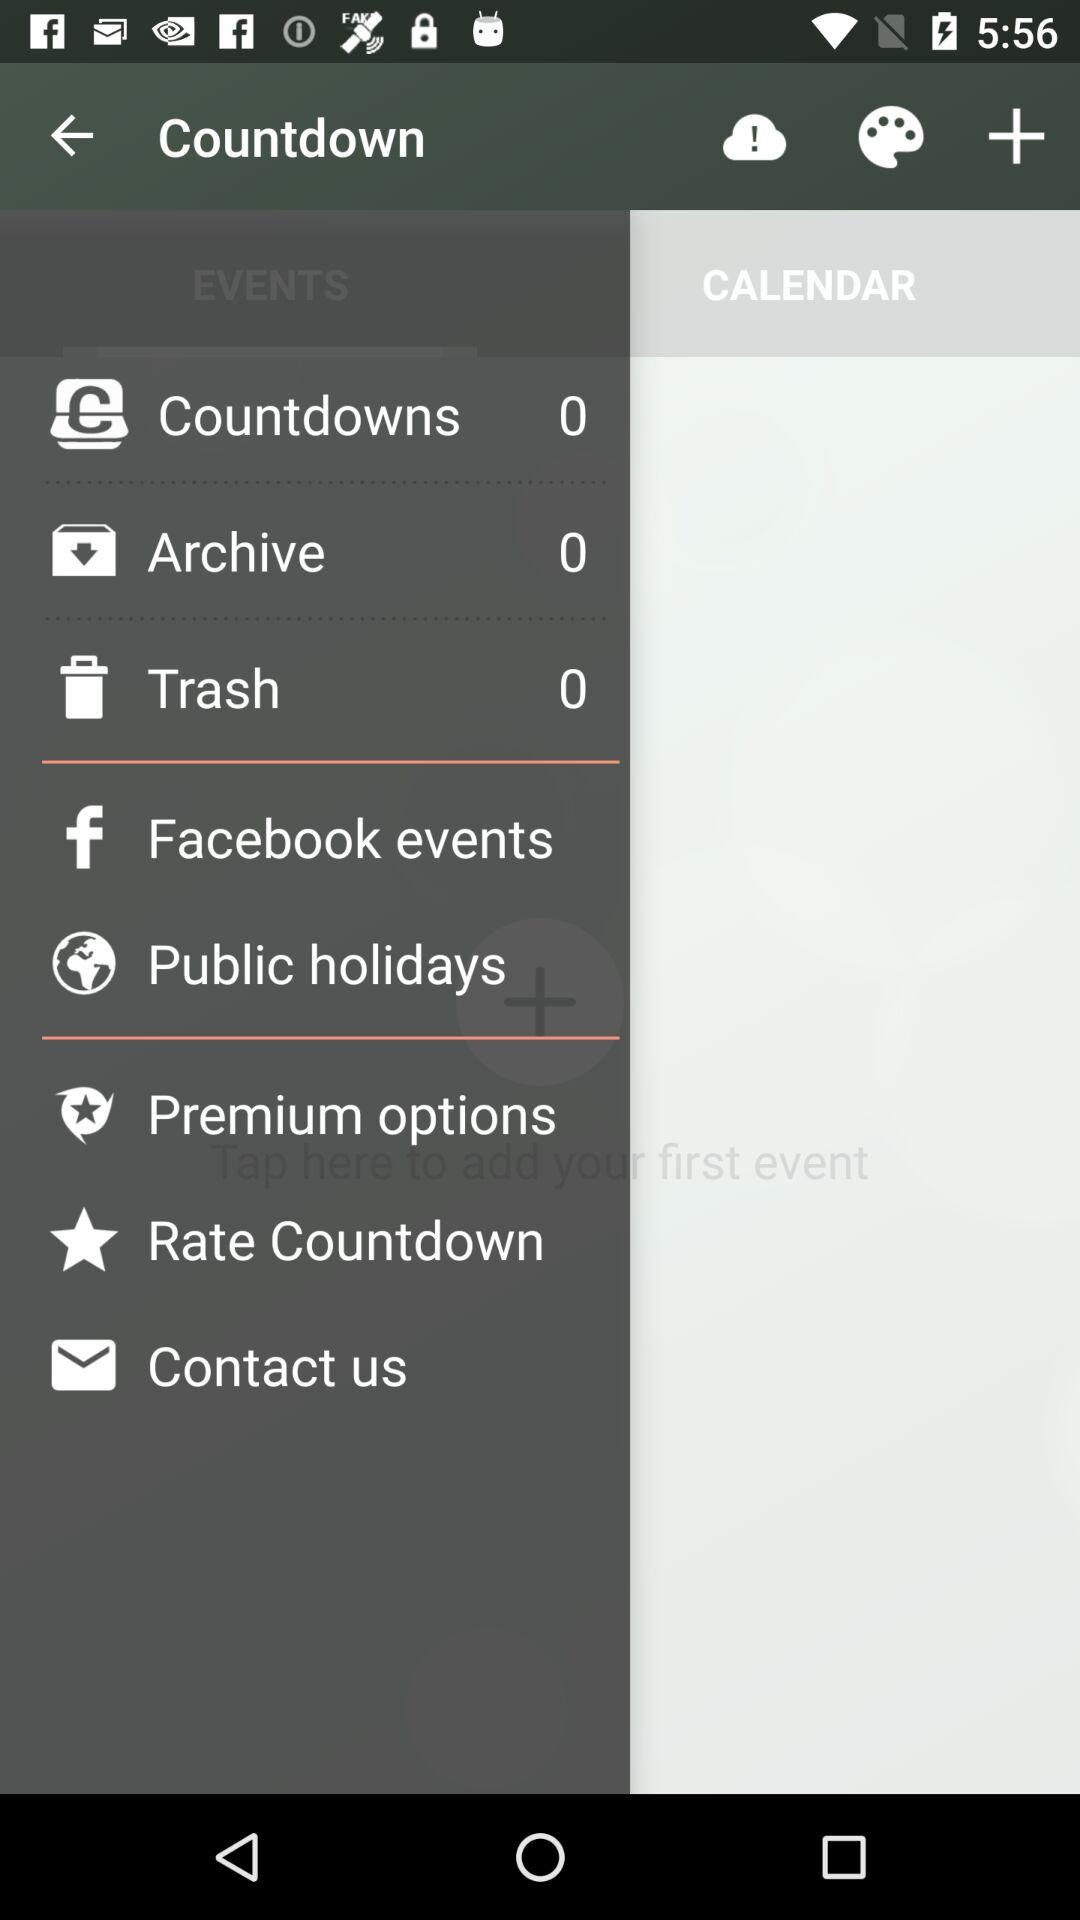What is the count of the archive? The count is 0. 